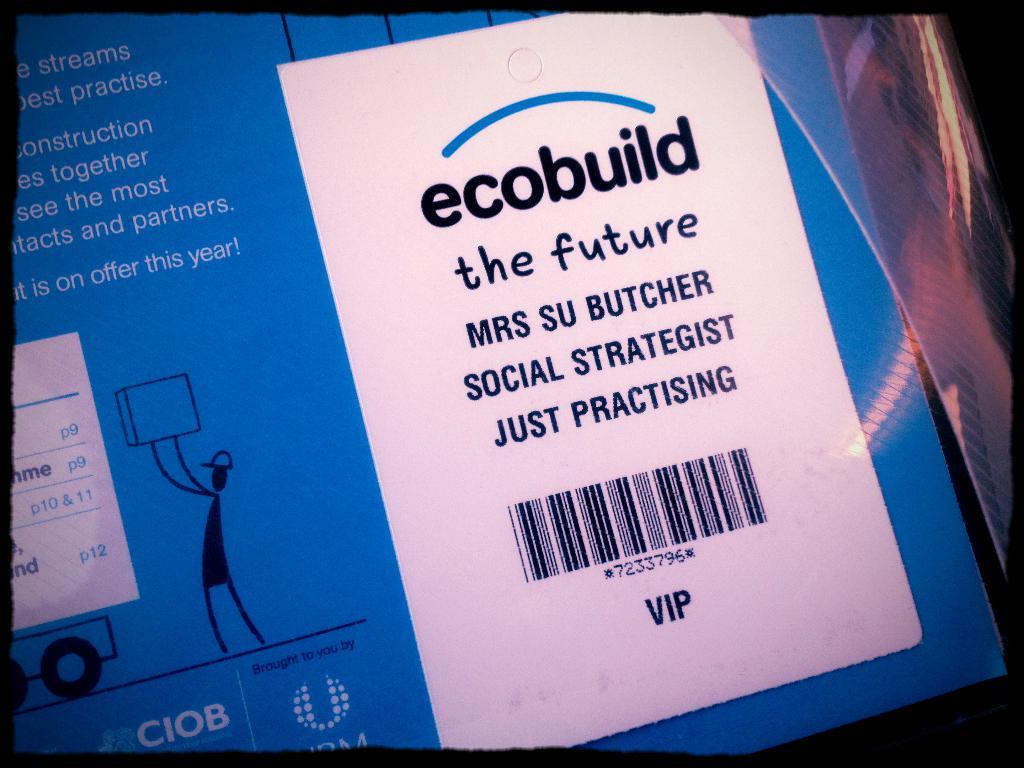<image>
Describe the image concisely. The label shown is claiming that ecobuild is the future. 